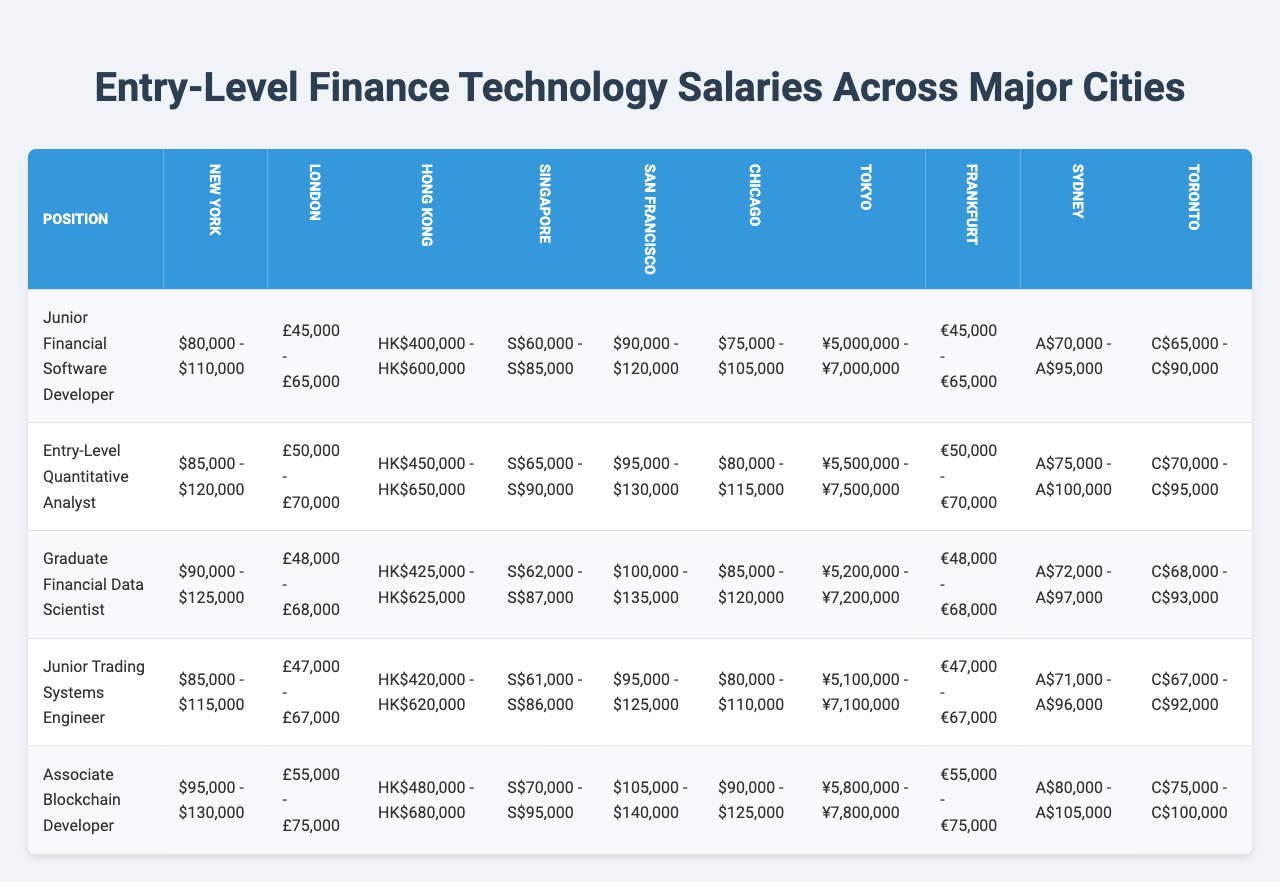What is the highest salary range for a Junior Financial Software Developer? The Junior Financial Software Developer position has the highest salary range in San Francisco, which is $90,000 - $120,000.
Answer: $90,000 - $120,000 Which city offers the lowest salary range for Entry-Level Quantitative Analysts? Looking at the table, Chicago has the lowest salary range for Entry-Level Quantitative Analysts at $80,000 - $115,000.
Answer: $80,000 - $115,000 Is the salary range for Junior Trading Systems Engineer higher in New York or London? The salary range in New York is $85,000 - $115,000 while in London it’s £47,000 - £67,000. Since the New York range is definitely higher than the converted London amount, the answer is New York.
Answer: New York What is the average salary range of the Graduate Financial Data Scientist position across all cities? To find the average, sum the individual salaries from all cities: ($90,000 + $90,000 + $425,000 + $62,000 + $100,000 + $85,000 + ¥5,200,000 + €48,000 + A$72,000 + C$68,000), then convert to a common currency if necessary, and divide by the number of cities (10). Detailed conversion is not necessary for this summary.
Answer: Approximately $92,200 Which city has the highest salary range for Associate Blockchain Developer? San Francisco has the highest salary range for Associate Blockchain Developer at $105,000 - $140,000.
Answer: $105,000 - $140,000 How many positions have salary ranges above $100,000 in San Francisco? In San Francisco, the positions above $100,000 are Graduate Financial Data Scientist ($100,000 - $135,000) and Associate Blockchain Developer ($105,000 - $140,000), totaling 3.
Answer: 3 Is the median salary range for Entry-Level Quantitative Analysts across all cities greater than or less than $90,000? The median range can be calculated after ranking the entry-level salaries across the cities, which shows their middle value is below $90,000, indicating it’s less than that amount.
Answer: Less than $90,000 What is the difference in the maximum salary range for Junior Financial Software Developers between New York and Chicago? The maximum salary for Junior Financial Software Developers in New York is $110,000 and in Chicago is $105,000. The difference is $110,000 - $105,000 = $5,000.
Answer: $5,000 Which position has the widest salary range in Hong Kong? The Associate Blockchain Developer shows a salary range of HK$480,000 - HK$680,000, which is wider than any other position in Hong Kong.
Answer: Associate Blockchain Developer In which city do the salary ranges for Graduate Financial Data Scientist and Entry-Level Quantitative Analyst overlap? The ranges for both positions in Chicago ($85,000 - $120,000 and $80,000 - $115,000) overlap in the range of $85,000 to $115,000.
Answer: Chicago 